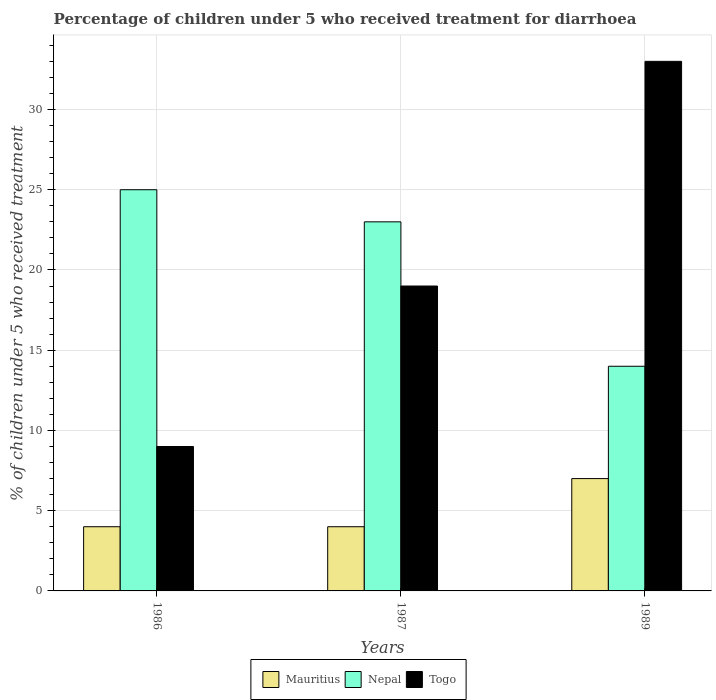How many groups of bars are there?
Make the answer very short. 3. Are the number of bars on each tick of the X-axis equal?
Ensure brevity in your answer.  Yes. How many bars are there on the 2nd tick from the left?
Give a very brief answer. 3. How many bars are there on the 3rd tick from the right?
Provide a succinct answer. 3. In which year was the percentage of children who received treatment for diarrhoea  in Togo maximum?
Provide a short and direct response. 1989. What is the total percentage of children who received treatment for diarrhoea  in Nepal in the graph?
Your answer should be compact. 62. What is the difference between the percentage of children who received treatment for diarrhoea  in Nepal in 1986 and that in 1987?
Ensure brevity in your answer.  2. What is the difference between the percentage of children who received treatment for diarrhoea  in Togo in 1987 and the percentage of children who received treatment for diarrhoea  in Mauritius in 1989?
Your response must be concise. 12. What is the average percentage of children who received treatment for diarrhoea  in Nepal per year?
Provide a short and direct response. 20.67. What is the ratio of the percentage of children who received treatment for diarrhoea  in Togo in 1986 to that in 1989?
Provide a short and direct response. 0.27. What is the difference between the highest and the second highest percentage of children who received treatment for diarrhoea  in Nepal?
Offer a terse response. 2. In how many years, is the percentage of children who received treatment for diarrhoea  in Nepal greater than the average percentage of children who received treatment for diarrhoea  in Nepal taken over all years?
Offer a very short reply. 2. Is the sum of the percentage of children who received treatment for diarrhoea  in Mauritius in 1986 and 1989 greater than the maximum percentage of children who received treatment for diarrhoea  in Nepal across all years?
Keep it short and to the point. No. What does the 3rd bar from the left in 1987 represents?
Provide a short and direct response. Togo. What does the 3rd bar from the right in 1987 represents?
Your answer should be very brief. Mauritius. How many bars are there?
Provide a succinct answer. 9. How many years are there in the graph?
Provide a short and direct response. 3. What is the difference between two consecutive major ticks on the Y-axis?
Your answer should be very brief. 5. Does the graph contain grids?
Offer a very short reply. Yes. How are the legend labels stacked?
Provide a succinct answer. Horizontal. What is the title of the graph?
Your response must be concise. Percentage of children under 5 who received treatment for diarrhoea. What is the label or title of the Y-axis?
Provide a short and direct response. % of children under 5 who received treatment. What is the % of children under 5 who received treatment of Nepal in 1986?
Make the answer very short. 25. What is the % of children under 5 who received treatment in Nepal in 1987?
Your answer should be compact. 23. What is the % of children under 5 who received treatment of Togo in 1987?
Your response must be concise. 19. What is the % of children under 5 who received treatment in Togo in 1989?
Offer a terse response. 33. Across all years, what is the maximum % of children under 5 who received treatment of Mauritius?
Your answer should be compact. 7. Across all years, what is the maximum % of children under 5 who received treatment in Togo?
Give a very brief answer. 33. Across all years, what is the minimum % of children under 5 who received treatment of Mauritius?
Provide a succinct answer. 4. Across all years, what is the minimum % of children under 5 who received treatment in Togo?
Your response must be concise. 9. What is the total % of children under 5 who received treatment in Nepal in the graph?
Offer a very short reply. 62. What is the total % of children under 5 who received treatment in Togo in the graph?
Offer a very short reply. 61. What is the difference between the % of children under 5 who received treatment of Nepal in 1986 and that in 1987?
Keep it short and to the point. 2. What is the difference between the % of children under 5 who received treatment of Mauritius in 1986 and that in 1989?
Offer a terse response. -3. What is the difference between the % of children under 5 who received treatment of Nepal in 1986 and that in 1989?
Keep it short and to the point. 11. What is the difference between the % of children under 5 who received treatment in Nepal in 1987 and that in 1989?
Give a very brief answer. 9. What is the difference between the % of children under 5 who received treatment of Mauritius in 1986 and the % of children under 5 who received treatment of Nepal in 1987?
Your answer should be very brief. -19. What is the difference between the % of children under 5 who received treatment of Mauritius in 1986 and the % of children under 5 who received treatment of Togo in 1987?
Your answer should be compact. -15. What is the difference between the % of children under 5 who received treatment of Mauritius in 1986 and the % of children under 5 who received treatment of Nepal in 1989?
Provide a short and direct response. -10. What is the average % of children under 5 who received treatment in Mauritius per year?
Your response must be concise. 5. What is the average % of children under 5 who received treatment of Nepal per year?
Provide a succinct answer. 20.67. What is the average % of children under 5 who received treatment in Togo per year?
Offer a very short reply. 20.33. In the year 1986, what is the difference between the % of children under 5 who received treatment of Mauritius and % of children under 5 who received treatment of Nepal?
Provide a succinct answer. -21. In the year 1986, what is the difference between the % of children under 5 who received treatment in Mauritius and % of children under 5 who received treatment in Togo?
Offer a very short reply. -5. In the year 1987, what is the difference between the % of children under 5 who received treatment of Nepal and % of children under 5 who received treatment of Togo?
Your answer should be compact. 4. In the year 1989, what is the difference between the % of children under 5 who received treatment of Mauritius and % of children under 5 who received treatment of Togo?
Your response must be concise. -26. In the year 1989, what is the difference between the % of children under 5 who received treatment of Nepal and % of children under 5 who received treatment of Togo?
Provide a succinct answer. -19. What is the ratio of the % of children under 5 who received treatment of Mauritius in 1986 to that in 1987?
Ensure brevity in your answer.  1. What is the ratio of the % of children under 5 who received treatment of Nepal in 1986 to that in 1987?
Your response must be concise. 1.09. What is the ratio of the % of children under 5 who received treatment in Togo in 1986 to that in 1987?
Give a very brief answer. 0.47. What is the ratio of the % of children under 5 who received treatment of Mauritius in 1986 to that in 1989?
Provide a short and direct response. 0.57. What is the ratio of the % of children under 5 who received treatment in Nepal in 1986 to that in 1989?
Give a very brief answer. 1.79. What is the ratio of the % of children under 5 who received treatment of Togo in 1986 to that in 1989?
Your answer should be very brief. 0.27. What is the ratio of the % of children under 5 who received treatment in Mauritius in 1987 to that in 1989?
Offer a terse response. 0.57. What is the ratio of the % of children under 5 who received treatment in Nepal in 1987 to that in 1989?
Provide a short and direct response. 1.64. What is the ratio of the % of children under 5 who received treatment in Togo in 1987 to that in 1989?
Ensure brevity in your answer.  0.58. What is the difference between the highest and the second highest % of children under 5 who received treatment of Togo?
Keep it short and to the point. 14. What is the difference between the highest and the lowest % of children under 5 who received treatment in Mauritius?
Your answer should be compact. 3. What is the difference between the highest and the lowest % of children under 5 who received treatment of Nepal?
Provide a short and direct response. 11. What is the difference between the highest and the lowest % of children under 5 who received treatment of Togo?
Your response must be concise. 24. 